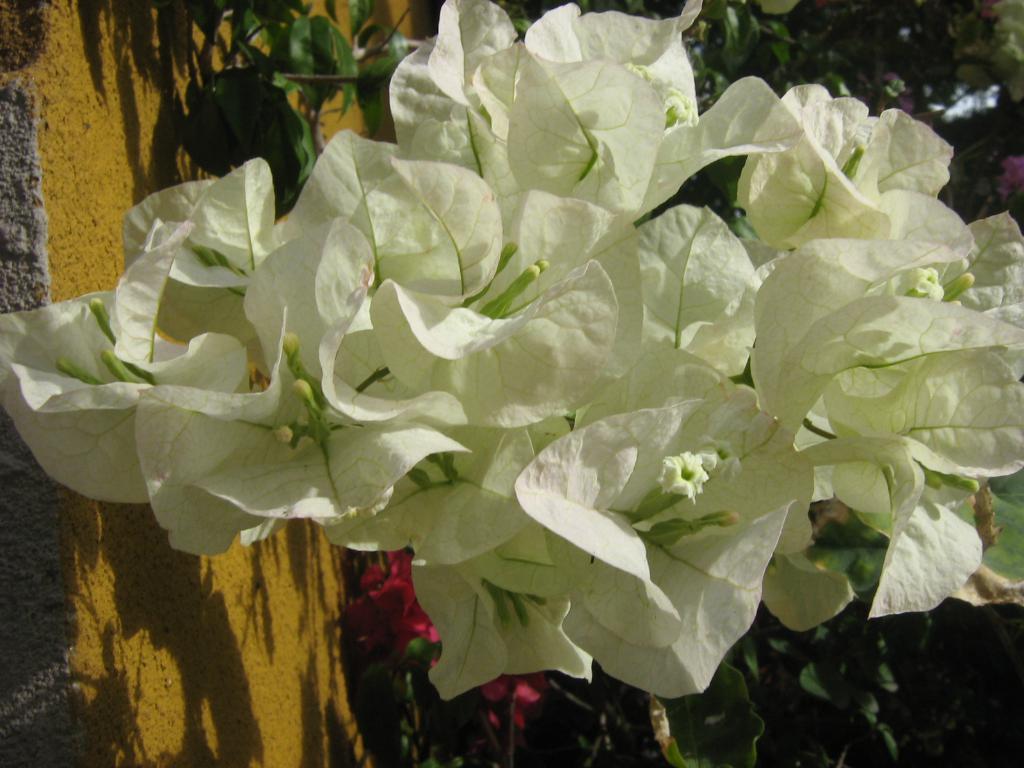Can you describe this image briefly? In front of the image there are flowers. Behind the flowers there are plants with leaves and flowers. 